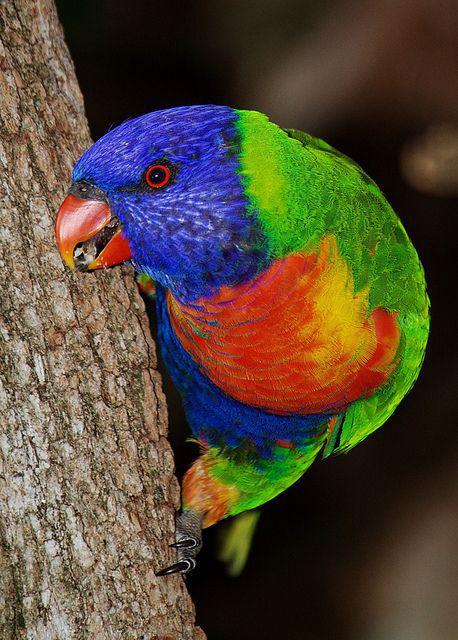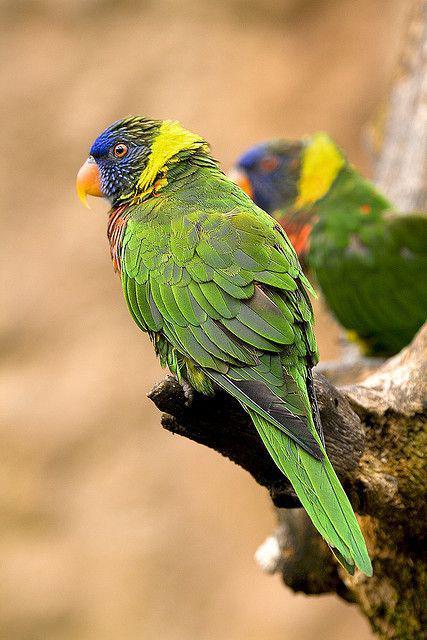The first image is the image on the left, the second image is the image on the right. For the images displayed, is the sentence "There are no more than four birds" factually correct? Answer yes or no. Yes. The first image is the image on the left, the second image is the image on the right. For the images shown, is this caption "Right image contains exactly one parrot." true? Answer yes or no. No. 